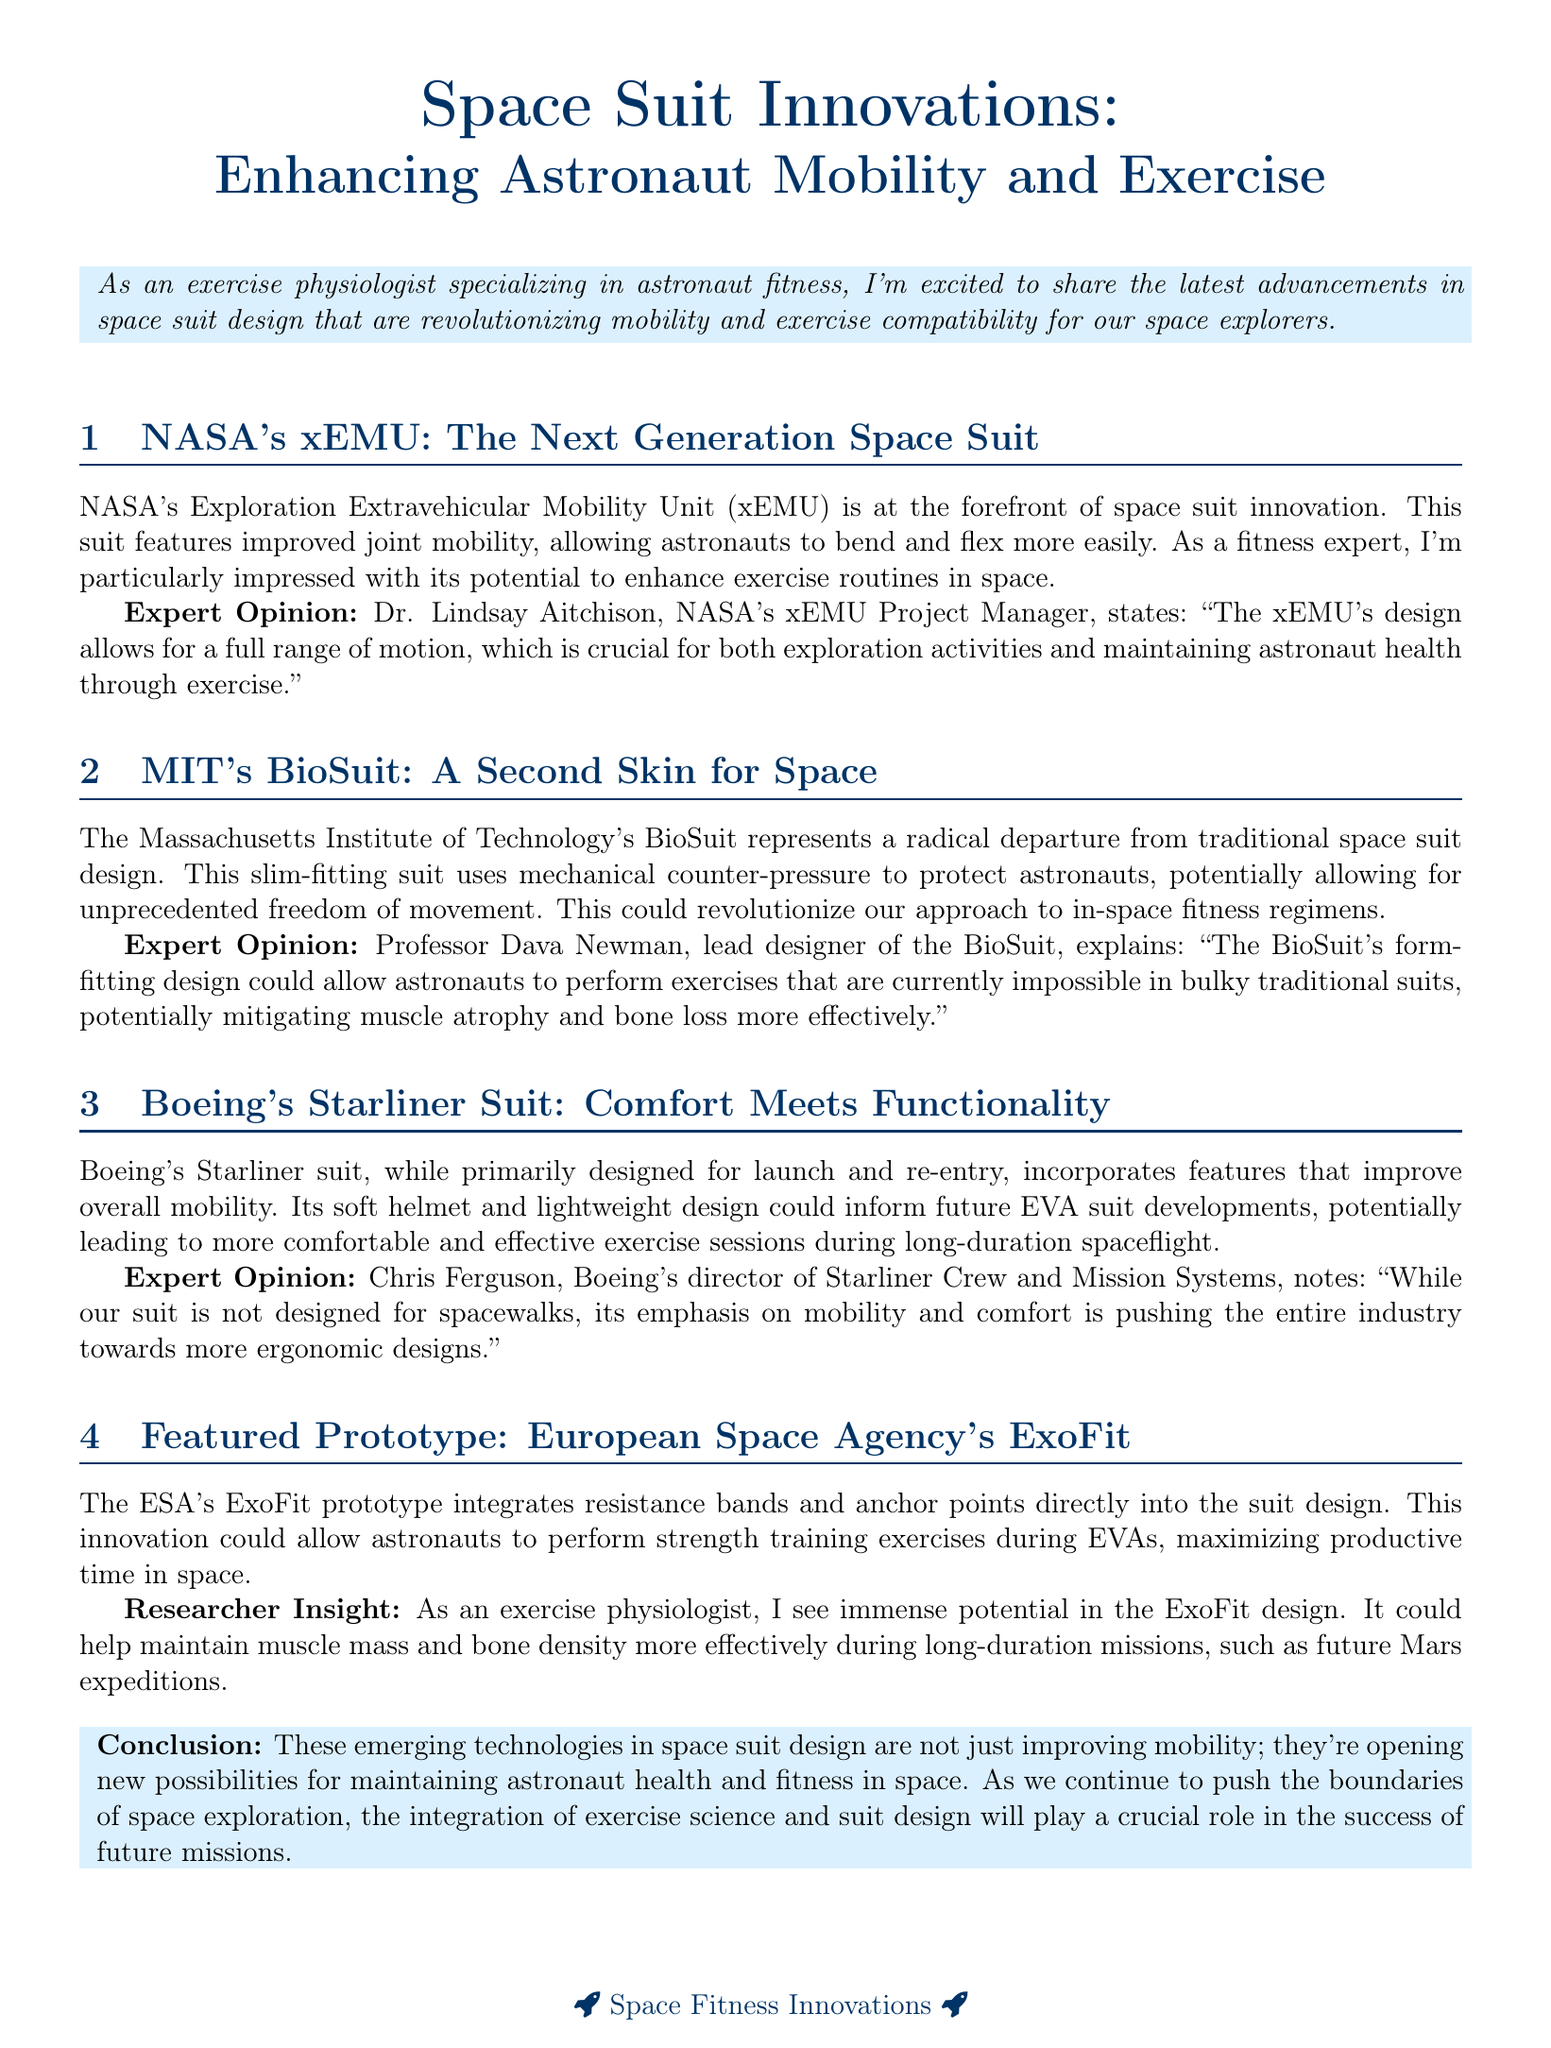What is the title of the newsletter? The title of the newsletter is the main heading that introduces the topic of the content being discussed.
Answer: Space Suit Innovations: Enhancing Astronaut Mobility and Exercise Who is the project manager for NASA's xEMU? This information can be found in the section discussing NASA's xEMU, where the expert opinion is presented.
Answer: Dr. Lindsay Aitchison What does MIT's BioSuit use for protection? The document states that the MIT's BioSuit utilizes a specific design strategy for astronaut protection.
Answer: Mechanical counter-pressure Which company developed the Starliner suit? The name of the company can be found in the section about the Starliner suit.
Answer: Boeing What is the unique feature of the ESA's ExoFit prototype? The unique feature is specified in the description of the ExoFit prototype.
Answer: Resistance bands and anchor points What is a key benefit of the xEMU design according to Dr. Aitchison? This information comes from the expert opinion section regarding the xEMU's benefits for astronauts.
Answer: Full range of motion How does the BioSuit potentially benefit astronauts during exercise? This is explained in Professor Newman's opinion on the BioSuit's capabilities.
Answer: Mitigating muscle atrophy and bone loss What is the main focus of the conclusion in the document? The conclusion summarizes the overall advancements discussed and their significance.
Answer: Maintaining astronaut health and fitness in space 